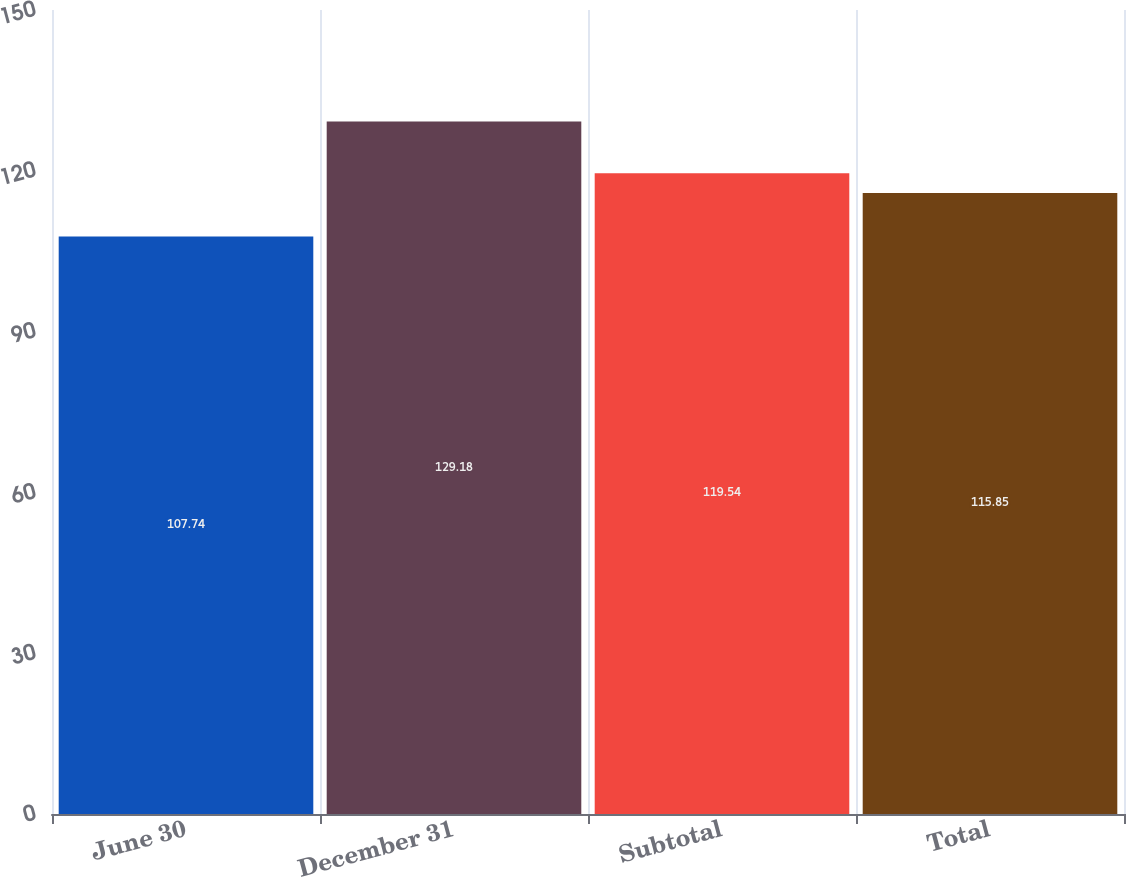Convert chart. <chart><loc_0><loc_0><loc_500><loc_500><bar_chart><fcel>June 30<fcel>December 31<fcel>Subtotal<fcel>Total<nl><fcel>107.74<fcel>129.18<fcel>119.54<fcel>115.85<nl></chart> 